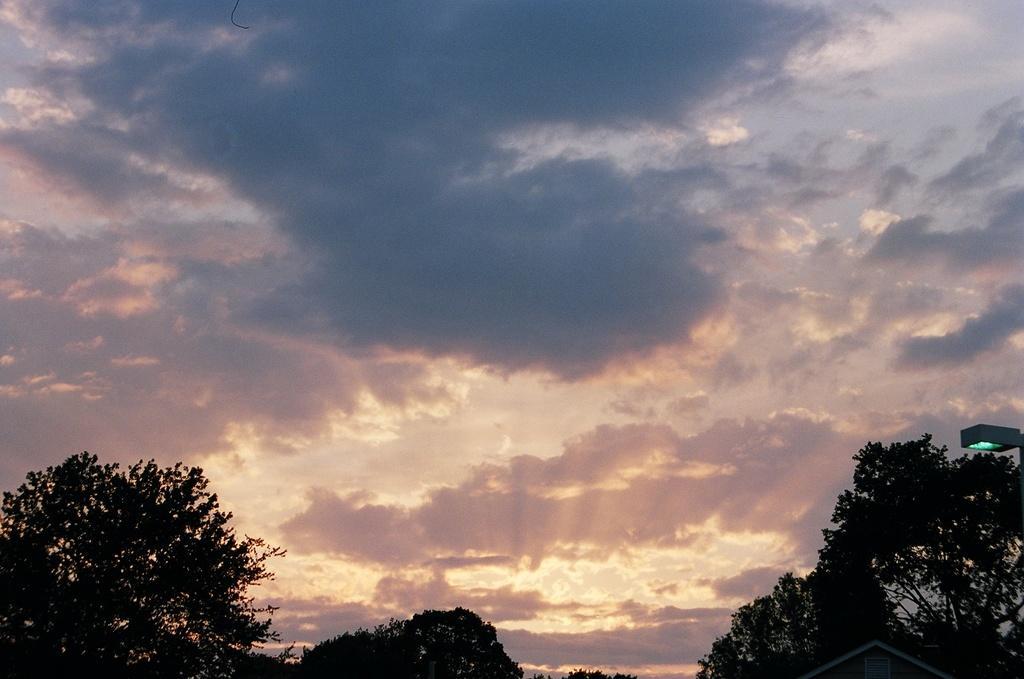Can you describe this image briefly? In this picture we can see some cloudy sky and we can see some trees. 